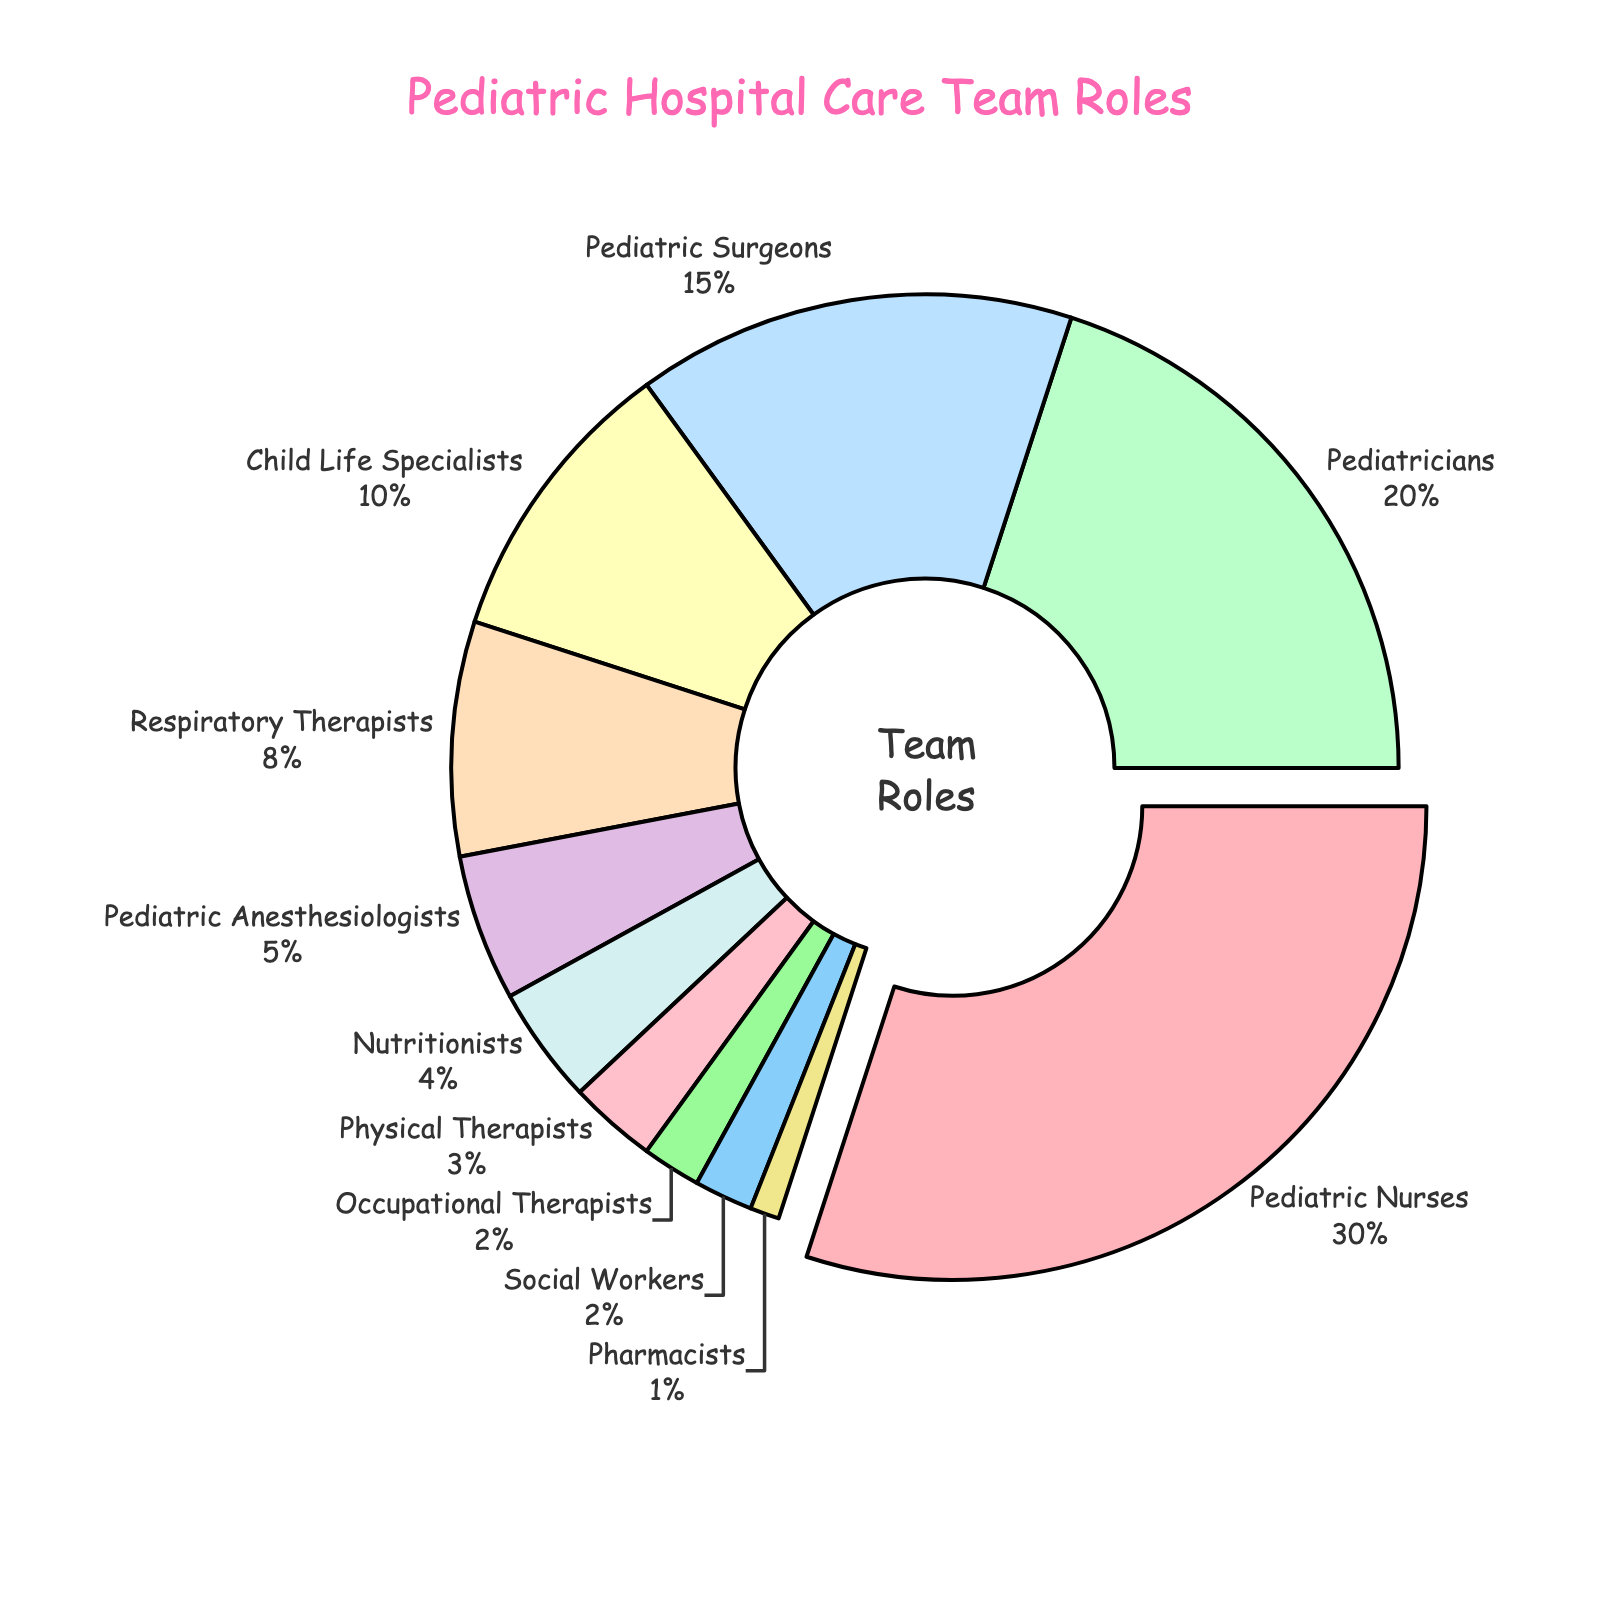What's the role with the highest percentage? Find the section of the pie chart that is most pulled out, which indicates the largest percentage. The label outside that section will give you the answer.
Answer: Pediatric Nurses Which two roles combined make up the same percentage as Pediatric Nurses? Pediatric Nurses make up 30%. To find two roles that sum to 30%, you can add the percentages of different roles together. Pediatricians (20%) and Child Life Specialists (10%) together make up 30%.
Answer: Pediatricians and Child Life Specialists Is the percentage of Pediatric Surgeons greater than the percentage of Physical Therapists? Look for the percentages associated with Pediatric Surgeons and Physical Therapists on the chart. Pediatric Surgeons are at 15%, and Physical Therapists are at 3%. 15% is greater than 3%.
Answer: Yes Which role has the smallest percentage and what is it? Locate the smallest section in the pie chart. The label outside this section and its corresponding percentage will provide the answer.
Answer: Pharmacists, 1% How much greater is the percentage of Pediatricians than Pediatric Anesthesiologists? Pediatricians make up 20% and Pediatric Anesthesiologists make up 5%. Subtract the percentage of Pediatric Anesthesiologists from the percentage of Pediatricians: 20% - 5% = 15%.
Answer: 15% Which color represents Child Life Specialists? Look for the section of the pie chart labeled "Child Life Specialists" and note the color of that section. Child Life Specialists are represented in blue (#FFFFBA).
Answer: Yellow How many roles have a percentage less than 5%? Look for all sections of the pie chart with percentages less than 5%. The roles with percentages less than 5% are Nutritionists, Physical Therapists, Occupational Therapists, Social Workers, and Pharmacists. There are 5 such roles.
Answer: 5 What is the combined percentage of all roles that are not Pediatric Nurses? Subtract the percentage of Pediatric Nurses from 100%. Pediatric Nurses make up 30%, so the combined percentage of all other roles is 100% - 30% = 70%.
Answer: 70% What is the difference in percentage between Respiratory Therapists and Nutritionists? Respiratory Therapists make up 8% and Nutritionists make up 4%. Subtract the percentage of Nutritionists from the percentage of Respiratory Therapists: 8% - 4% = 4%.
Answer: 4% Which role is represented by pink in the pie chart? Look for the section that is colored pink. The label outside this section will provide the answer.
Answer: Pediatric Surgeons 